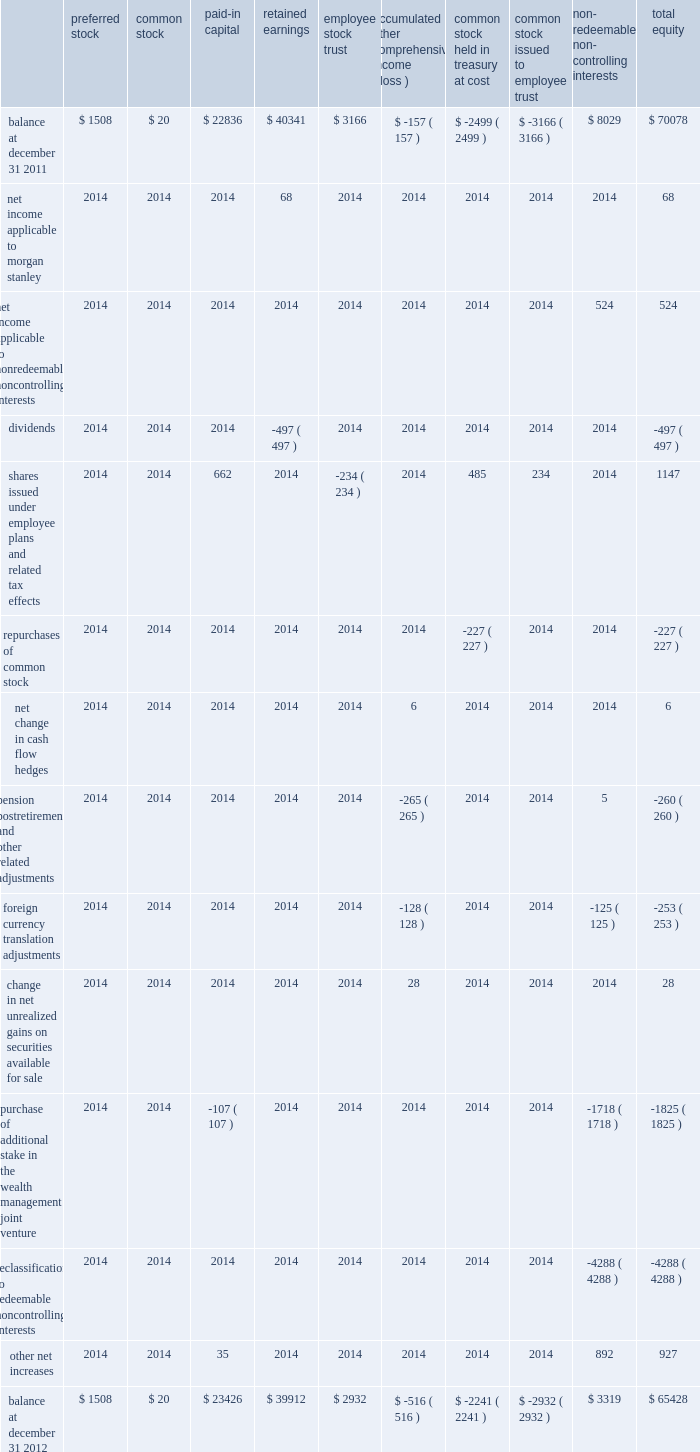Morgan stanley consolidated statements of changes in total equity 2014 ( continued ) ( dollars in millions ) preferred common paid-in capital retained earnings employee accumulated comprehensive income ( loss ) common held in treasury at cost common issued to employee redeemable controlling interests equity balance at december 31 , 2011 .
$ 1508 $ 20 $ 22836 $ 40341 $ 3166 $ ( 157 ) $ ( 2499 ) $ ( 3166 ) $ 8029 $ 70078 net income applicable to morgan stanley .
2014 2014 2014 68 2014 2014 2014 2014 2014 68 net income applicable to nonredeemable noncontrolling interests .
2014 2014 2014 2014 2014 2014 2014 2014 524 524 .
Balance at december 31 , 2012 .
$ 1508 $ 20 $ 23426 $ 39912 $ 2932 $ ( 516 ) $ ( 2241 ) $ ( 2932 ) $ 3319 $ 65428 see notes to consolidated financial statements. .
What was total cash retuned to shareholders in 2012? 
Rationale: dividends plus stock repurchases?
Computations: (497 + 227)
Answer: 724.0. 